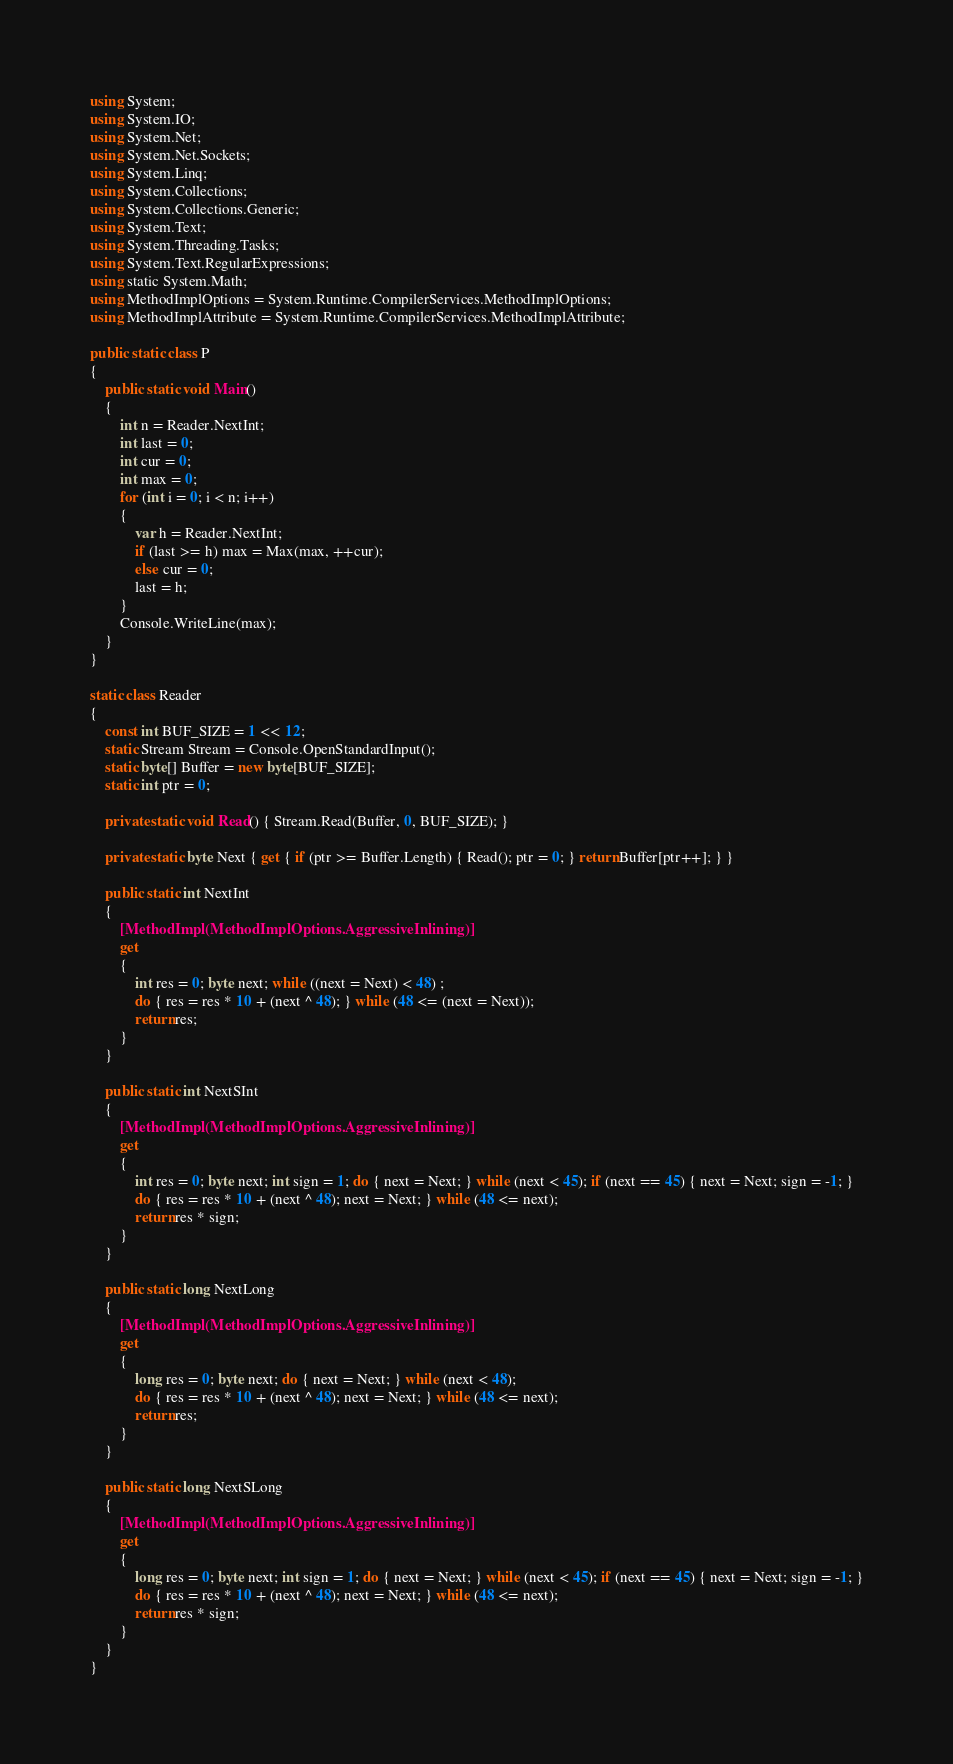Convert code to text. <code><loc_0><loc_0><loc_500><loc_500><_C#_>using System;
using System.IO;
using System.Net;
using System.Net.Sockets;
using System.Linq;
using System.Collections;
using System.Collections.Generic;
using System.Text;
using System.Threading.Tasks;
using System.Text.RegularExpressions;
using static System.Math;
using MethodImplOptions = System.Runtime.CompilerServices.MethodImplOptions;
using MethodImplAttribute = System.Runtime.CompilerServices.MethodImplAttribute;

public static class P
{
    public static void Main()
    {
        int n = Reader.NextInt;
        int last = 0;
        int cur = 0;
        int max = 0;
        for (int i = 0; i < n; i++)
        {
            var h = Reader.NextInt;
            if (last >= h) max = Max(max, ++cur);
            else cur = 0;
            last = h;
        }
        Console.WriteLine(max);
    }
}

static class Reader
{
    const int BUF_SIZE = 1 << 12;
    static Stream Stream = Console.OpenStandardInput();
    static byte[] Buffer = new byte[BUF_SIZE];
    static int ptr = 0;

    private static void Read() { Stream.Read(Buffer, 0, BUF_SIZE); }

    private static byte Next { get { if (ptr >= Buffer.Length) { Read(); ptr = 0; } return Buffer[ptr++]; } }

    public static int NextInt
    {
        [MethodImpl(MethodImplOptions.AggressiveInlining)]
        get
        {
            int res = 0; byte next; while ((next = Next) < 48) ;
            do { res = res * 10 + (next ^ 48); } while (48 <= (next = Next));
            return res;
        }
    }

    public static int NextSInt
    {
        [MethodImpl(MethodImplOptions.AggressiveInlining)]
        get
        {
            int res = 0; byte next; int sign = 1; do { next = Next; } while (next < 45); if (next == 45) { next = Next; sign = -1; }
            do { res = res * 10 + (next ^ 48); next = Next; } while (48 <= next);
            return res * sign;
        }
    }

    public static long NextLong
    {
        [MethodImpl(MethodImplOptions.AggressiveInlining)]
        get
        {
            long res = 0; byte next; do { next = Next; } while (next < 48);
            do { res = res * 10 + (next ^ 48); next = Next; } while (48 <= next);
            return res;
        }
    }

    public static long NextSLong
    {
        [MethodImpl(MethodImplOptions.AggressiveInlining)]
        get
        {
            long res = 0; byte next; int sign = 1; do { next = Next; } while (next < 45); if (next == 45) { next = Next; sign = -1; }
            do { res = res * 10 + (next ^ 48); next = Next; } while (48 <= next);
            return res * sign;
        }
    }
}
</code> 